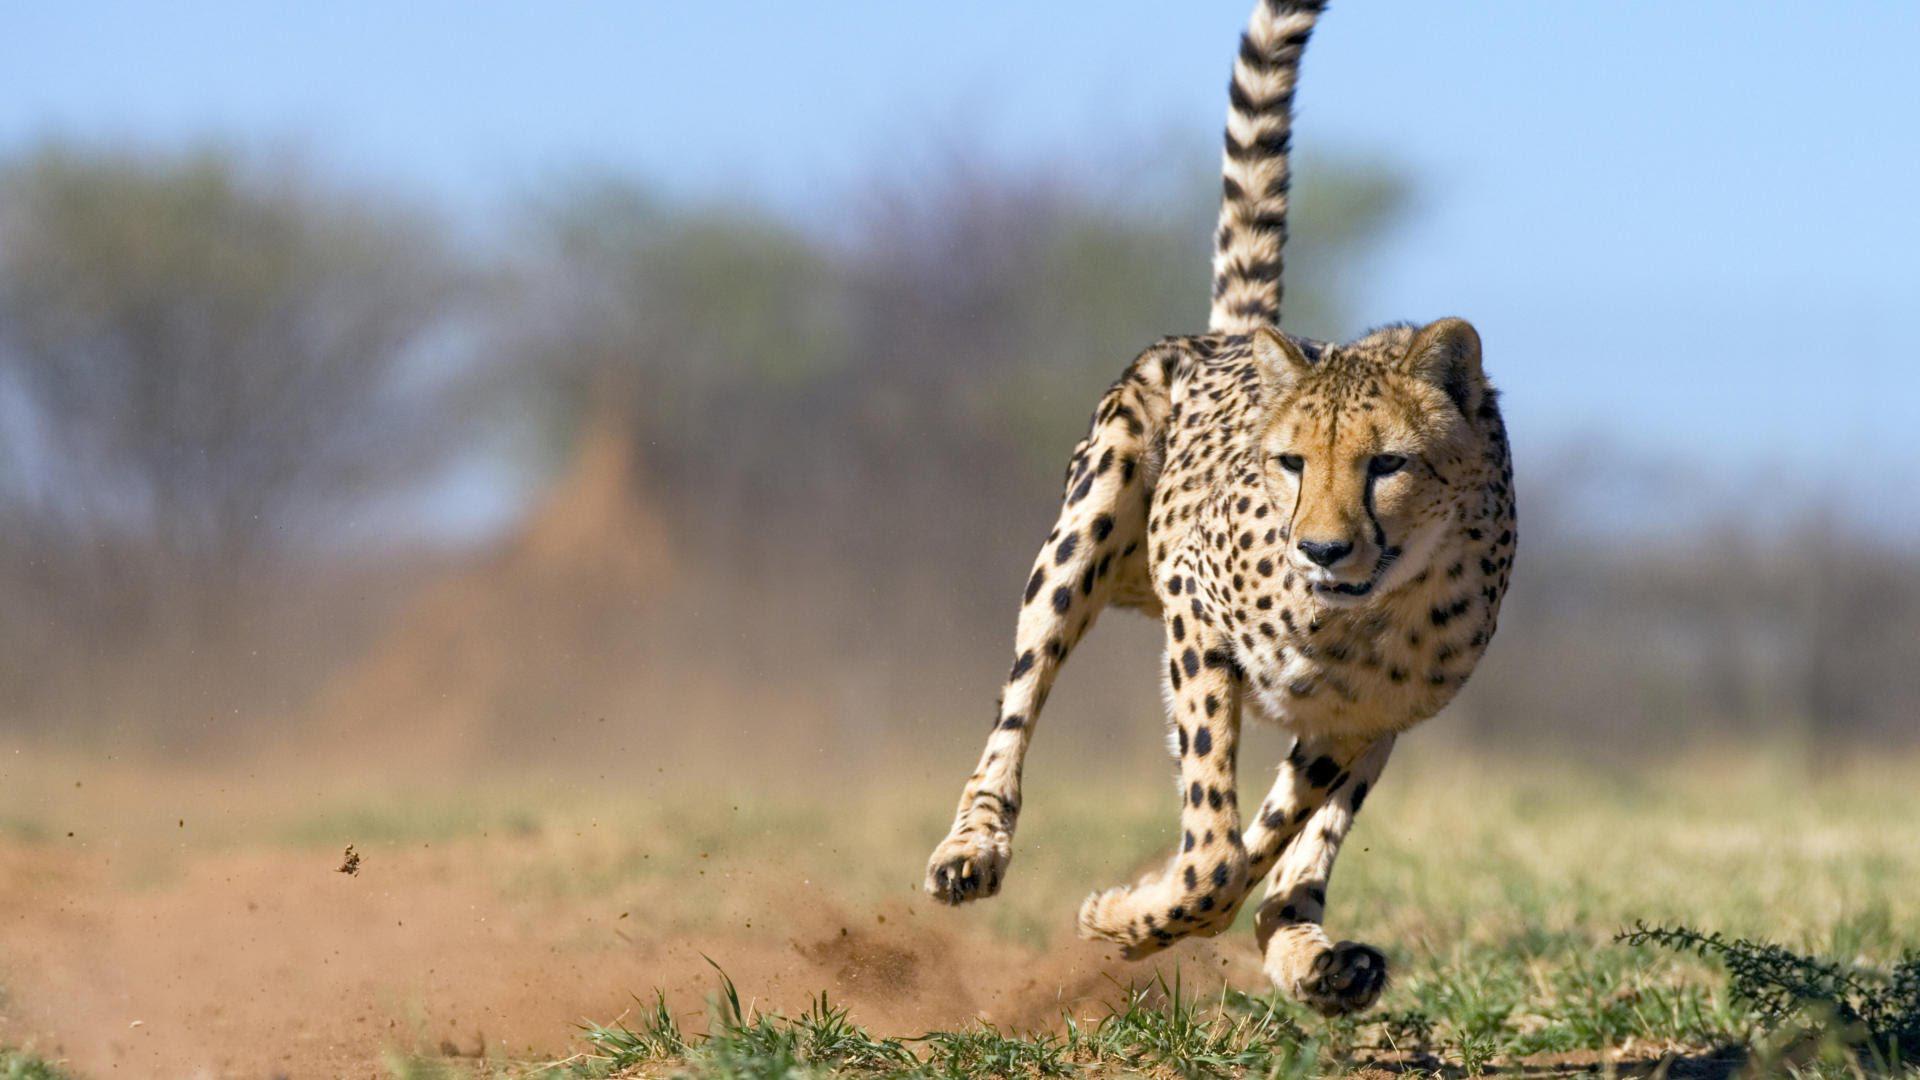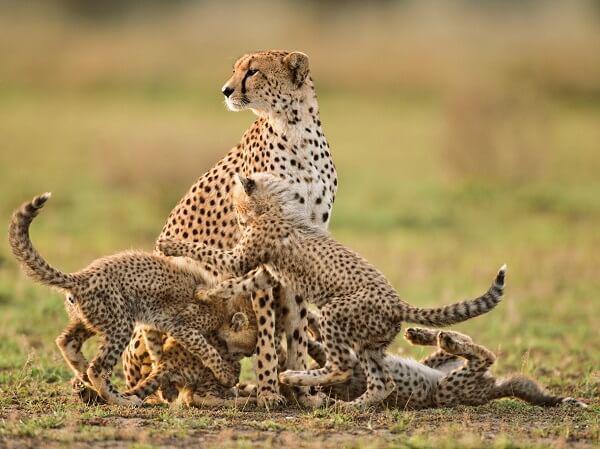The first image is the image on the left, the second image is the image on the right. Given the left and right images, does the statement "A single cheetah is leaping in the air in the left image." hold true? Answer yes or no. Yes. The first image is the image on the left, the second image is the image on the right. Assess this claim about the two images: "There is a mother cheetah sitting and watching as her 3 cubs are close to her". Correct or not? Answer yes or no. Yes. 